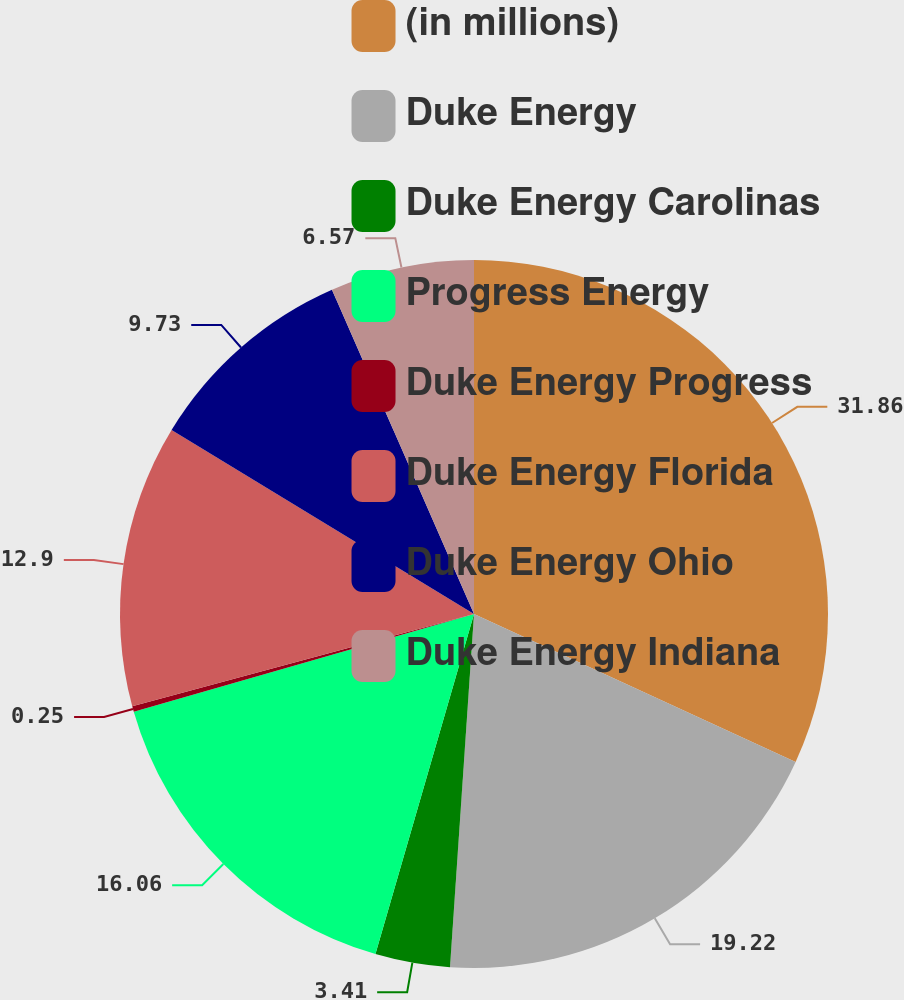Convert chart to OTSL. <chart><loc_0><loc_0><loc_500><loc_500><pie_chart><fcel>(in millions)<fcel>Duke Energy<fcel>Duke Energy Carolinas<fcel>Progress Energy<fcel>Duke Energy Progress<fcel>Duke Energy Florida<fcel>Duke Energy Ohio<fcel>Duke Energy Indiana<nl><fcel>31.86%<fcel>19.22%<fcel>3.41%<fcel>16.06%<fcel>0.25%<fcel>12.9%<fcel>9.73%<fcel>6.57%<nl></chart> 